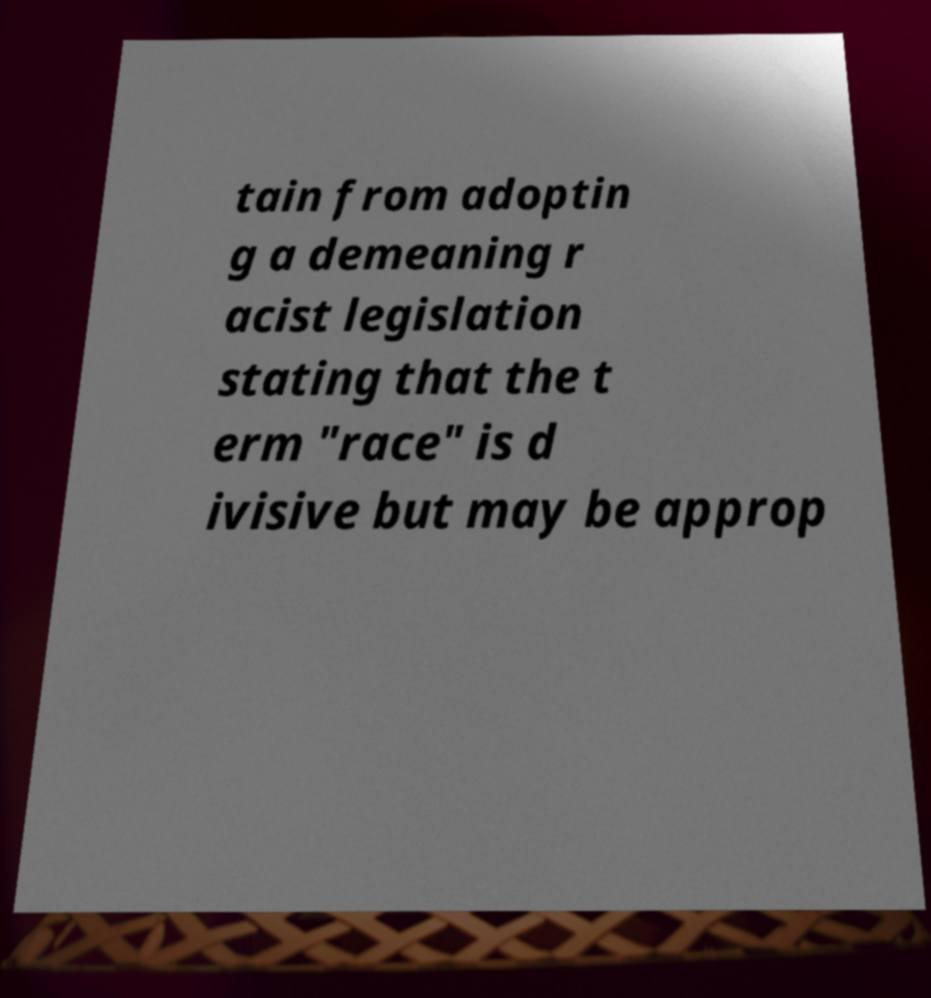Please read and relay the text visible in this image. What does it say? tain from adoptin g a demeaning r acist legislation stating that the t erm "race" is d ivisive but may be approp 